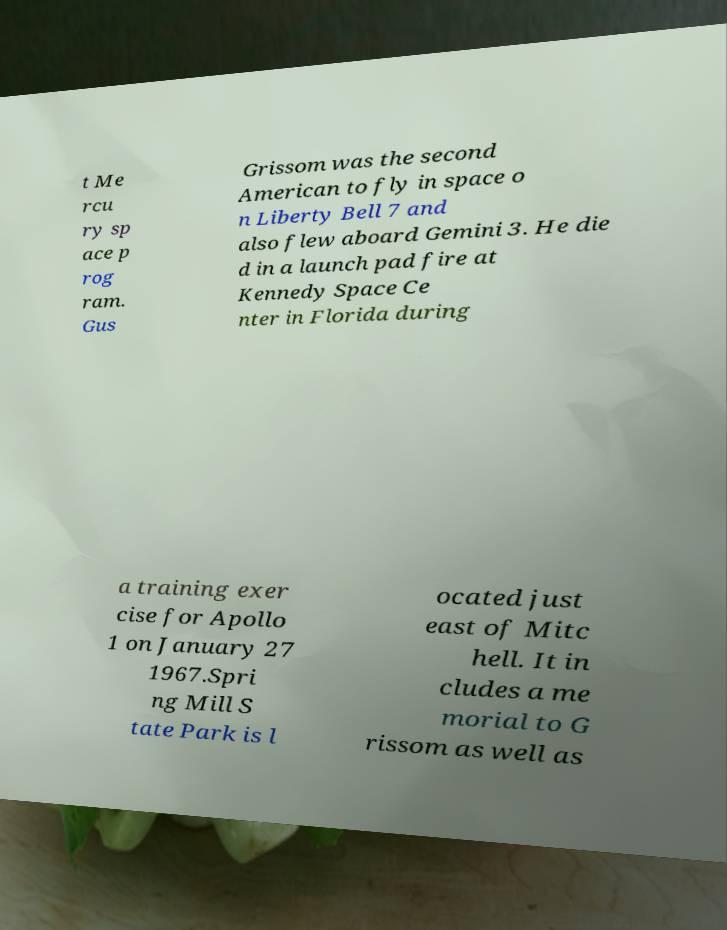For documentation purposes, I need the text within this image transcribed. Could you provide that? t Me rcu ry sp ace p rog ram. Gus Grissom was the second American to fly in space o n Liberty Bell 7 and also flew aboard Gemini 3. He die d in a launch pad fire at Kennedy Space Ce nter in Florida during a training exer cise for Apollo 1 on January 27 1967.Spri ng Mill S tate Park is l ocated just east of Mitc hell. It in cludes a me morial to G rissom as well as 